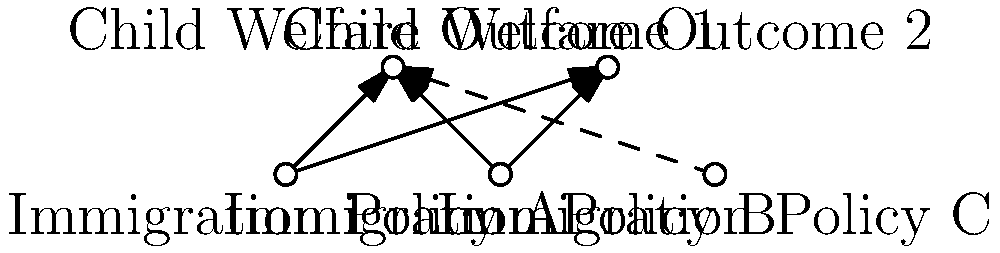Based on the network diagram showing connections between immigration policies and child welfare outcomes, which immigration policy appears to have the weakest influence on the depicted child welfare outcomes? To determine which immigration policy has the weakest influence on the child welfare outcomes, we need to analyze the connections in the network diagram:

1. Identify the immigration policies:
   - Immigration Policy A
   - Immigration Policy B
   - Immigration Policy C

2. Identify the child welfare outcomes:
   - Child Welfare Outcome 1
   - Child Welfare Outcome 2

3. Analyze the connections:
   - Immigration Policy A has solid arrows to both Child Welfare Outcome 1 and 2
   - Immigration Policy B has solid arrows to both Child Welfare Outcome 1 and 2
   - Immigration Policy C has a dashed arrow only to Child Welfare Outcome 1

4. Interpret the connections:
   - Solid arrows indicate strong or direct influences
   - Dashed arrows indicate weak or indirect influences

5. Compare the influences:
   - Policies A and B have strong influences on both outcomes
   - Policy C has a weak influence on only one outcome

Therefore, Immigration Policy C appears to have the weakest influence on the depicted child welfare outcomes.
Answer: Immigration Policy C 